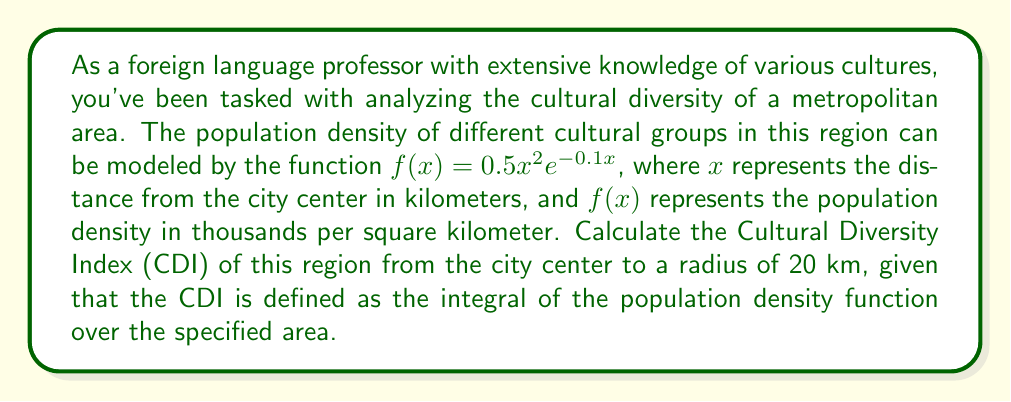Could you help me with this problem? To solve this problem, we need to use integral calculus to compute the Cultural Diversity Index (CDI) over the given region. The steps are as follows:

1) The CDI is defined as the integral of the population density function over the specified area. In this case, we need to integrate $f(x) = 0.5x^2e^{-0.1x}$ from 0 to 20 km.

2) Set up the integral:

   $$CDI = \int_0^{20} 0.5x^2e^{-0.1x} dx$$

3) This integral cannot be solved using elementary antiderivatives. We need to use integration by parts twice. Let's define $u = x^2$ and $dv = e^{-0.1x}dx$.

4) First integration by parts:
   $$\int x^2e^{-0.1x} dx = -10x^2e^{-0.1x} + 20\int xe^{-0.1x} dx$$

5) For the remaining integral, let $u = x$ and $dv = e^{-0.1x}dx$. Second integration by parts:
   $$20\int xe^{-0.1x} dx = -200xe^{-0.1x} + 2000\int e^{-0.1x} dx$$

6) Combining the results:
   $$\int x^2e^{-0.1x} dx = -10x^2e^{-0.1x} - 200xe^{-0.1x} - 20000e^{-0.1x} + C$$

7) Now, we can evaluate the definite integral:

   $$CDI = 0.5 \left[ (-10x^2e^{-0.1x} - 200xe^{-0.1x} - 20000e^{-0.1x}) \right]_0^{20}$$

8) Plugging in the limits:
   $$CDI = 0.5 \left[ (-10(20)^2e^{-2} - 200(20)e^{-2} - 20000e^{-2}) - (-10(0)^2e^{0} - 200(0)e^{0} - 20000e^{0}) \right]$$

9) Simplify:
   $$CDI = 0.5 \left[ (-4000e^{-2} - 4000e^{-2} - 20000e^{-2}) - (-20000) \right]$$
   $$CDI = 0.5 \left[ -28000e^{-2} + 20000 \right]$$

10) Calculate the final result:
    $$CDI \approx 9026.45$$
Answer: The Cultural Diversity Index (CDI) of the region from the city center to a radius of 20 km is approximately 9026.45. 